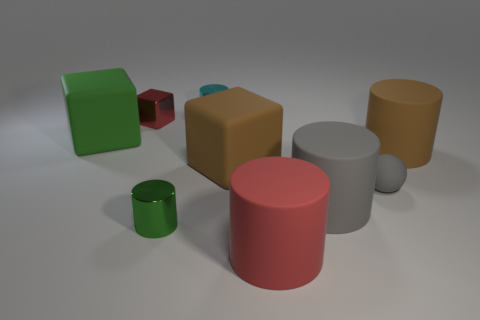Subtract all large red cylinders. How many cylinders are left? 4 Subtract all red cylinders. How many cylinders are left? 4 Subtract all yellow cylinders. Subtract all red balls. How many cylinders are left? 5 Add 1 brown things. How many objects exist? 10 Subtract all cubes. How many objects are left? 6 Subtract all small objects. Subtract all tiny red shiny blocks. How many objects are left? 4 Add 5 blocks. How many blocks are left? 8 Add 9 green blocks. How many green blocks exist? 10 Subtract 0 blue cylinders. How many objects are left? 9 